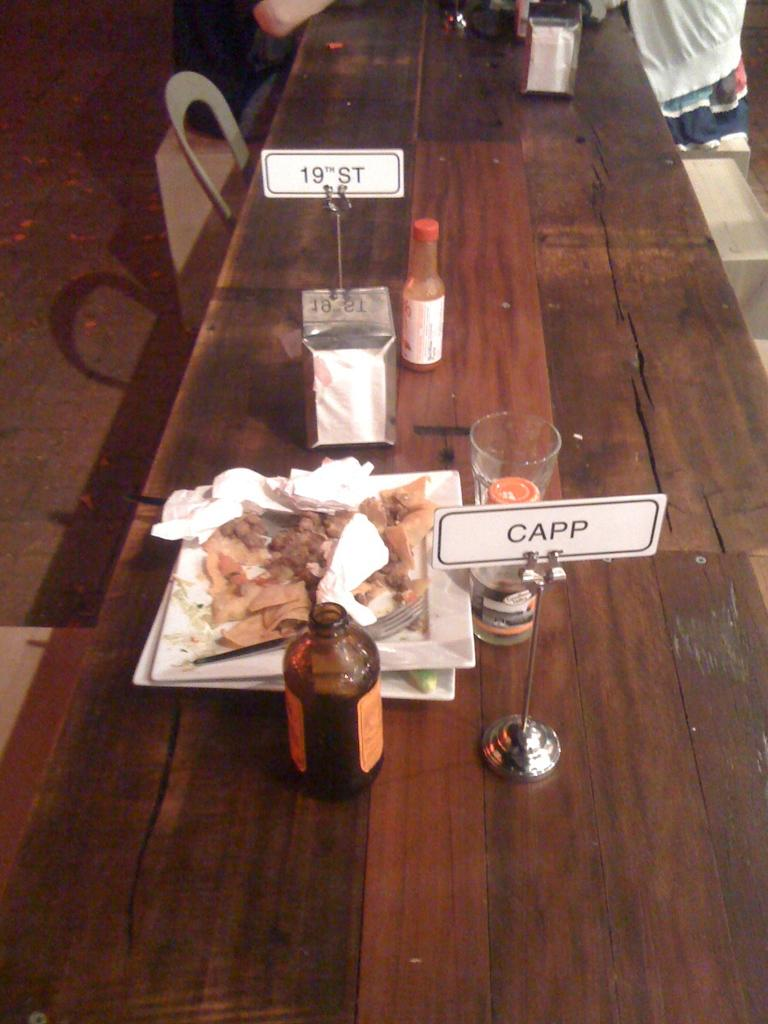<image>
Relay a brief, clear account of the picture shown. A little sign on a table says "CAPP" and is sitting next to a messy plate of food. 